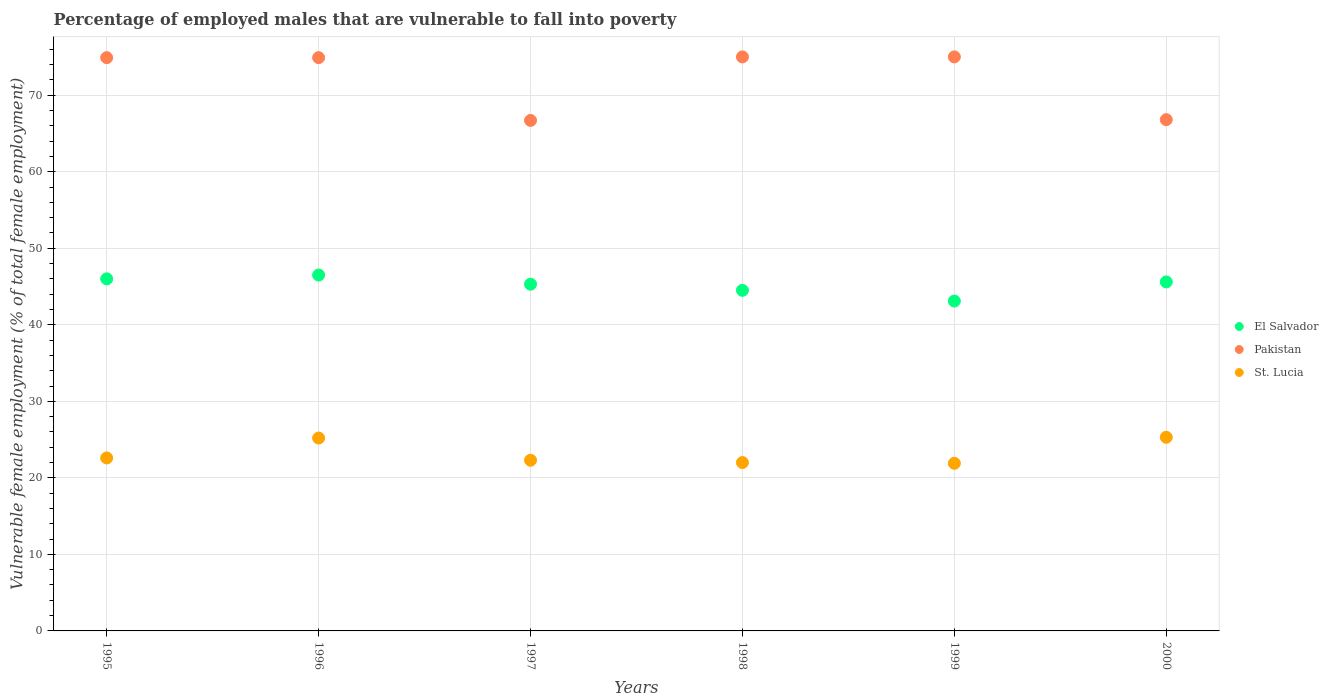Is the number of dotlines equal to the number of legend labels?
Provide a short and direct response. Yes. What is the percentage of employed males who are vulnerable to fall into poverty in Pakistan in 1996?
Your response must be concise. 74.9. Across all years, what is the maximum percentage of employed males who are vulnerable to fall into poverty in El Salvador?
Your answer should be compact. 46.5. Across all years, what is the minimum percentage of employed males who are vulnerable to fall into poverty in Pakistan?
Offer a very short reply. 66.7. In which year was the percentage of employed males who are vulnerable to fall into poverty in El Salvador minimum?
Give a very brief answer. 1999. What is the total percentage of employed males who are vulnerable to fall into poverty in St. Lucia in the graph?
Keep it short and to the point. 139.3. What is the difference between the percentage of employed males who are vulnerable to fall into poverty in El Salvador in 1995 and that in 2000?
Make the answer very short. 0.4. What is the difference between the percentage of employed males who are vulnerable to fall into poverty in St. Lucia in 1995 and the percentage of employed males who are vulnerable to fall into poverty in Pakistan in 1997?
Your answer should be very brief. -44.1. What is the average percentage of employed males who are vulnerable to fall into poverty in El Salvador per year?
Provide a short and direct response. 45.17. In the year 1999, what is the difference between the percentage of employed males who are vulnerable to fall into poverty in St. Lucia and percentage of employed males who are vulnerable to fall into poverty in Pakistan?
Make the answer very short. -53.1. In how many years, is the percentage of employed males who are vulnerable to fall into poverty in Pakistan greater than 64 %?
Provide a succinct answer. 6. What is the ratio of the percentage of employed males who are vulnerable to fall into poverty in Pakistan in 1997 to that in 2000?
Provide a succinct answer. 1. Is the percentage of employed males who are vulnerable to fall into poverty in El Salvador in 1998 less than that in 2000?
Offer a very short reply. Yes. Is the difference between the percentage of employed males who are vulnerable to fall into poverty in St. Lucia in 1997 and 2000 greater than the difference between the percentage of employed males who are vulnerable to fall into poverty in Pakistan in 1997 and 2000?
Provide a succinct answer. No. What is the difference between the highest and the lowest percentage of employed males who are vulnerable to fall into poverty in El Salvador?
Your response must be concise. 3.4. In how many years, is the percentage of employed males who are vulnerable to fall into poverty in El Salvador greater than the average percentage of employed males who are vulnerable to fall into poverty in El Salvador taken over all years?
Offer a terse response. 4. Is the sum of the percentage of employed males who are vulnerable to fall into poverty in St. Lucia in 1997 and 1998 greater than the maximum percentage of employed males who are vulnerable to fall into poverty in El Salvador across all years?
Ensure brevity in your answer.  No. Is it the case that in every year, the sum of the percentage of employed males who are vulnerable to fall into poverty in St. Lucia and percentage of employed males who are vulnerable to fall into poverty in Pakistan  is greater than the percentage of employed males who are vulnerable to fall into poverty in El Salvador?
Offer a terse response. Yes. Does the percentage of employed males who are vulnerable to fall into poverty in St. Lucia monotonically increase over the years?
Make the answer very short. No. Is the percentage of employed males who are vulnerable to fall into poverty in Pakistan strictly less than the percentage of employed males who are vulnerable to fall into poverty in El Salvador over the years?
Ensure brevity in your answer.  No. How many years are there in the graph?
Your answer should be very brief. 6. What is the difference between two consecutive major ticks on the Y-axis?
Offer a terse response. 10. Are the values on the major ticks of Y-axis written in scientific E-notation?
Provide a succinct answer. No. What is the title of the graph?
Offer a very short reply. Percentage of employed males that are vulnerable to fall into poverty. What is the label or title of the Y-axis?
Provide a short and direct response. Vulnerable female employment (% of total female employment). What is the Vulnerable female employment (% of total female employment) of Pakistan in 1995?
Your answer should be compact. 74.9. What is the Vulnerable female employment (% of total female employment) of St. Lucia in 1995?
Your response must be concise. 22.6. What is the Vulnerable female employment (% of total female employment) of El Salvador in 1996?
Your response must be concise. 46.5. What is the Vulnerable female employment (% of total female employment) of Pakistan in 1996?
Give a very brief answer. 74.9. What is the Vulnerable female employment (% of total female employment) in St. Lucia in 1996?
Give a very brief answer. 25.2. What is the Vulnerable female employment (% of total female employment) of El Salvador in 1997?
Provide a succinct answer. 45.3. What is the Vulnerable female employment (% of total female employment) of Pakistan in 1997?
Give a very brief answer. 66.7. What is the Vulnerable female employment (% of total female employment) of St. Lucia in 1997?
Provide a short and direct response. 22.3. What is the Vulnerable female employment (% of total female employment) in El Salvador in 1998?
Give a very brief answer. 44.5. What is the Vulnerable female employment (% of total female employment) of Pakistan in 1998?
Provide a short and direct response. 75. What is the Vulnerable female employment (% of total female employment) in El Salvador in 1999?
Give a very brief answer. 43.1. What is the Vulnerable female employment (% of total female employment) in St. Lucia in 1999?
Your answer should be very brief. 21.9. What is the Vulnerable female employment (% of total female employment) in El Salvador in 2000?
Give a very brief answer. 45.6. What is the Vulnerable female employment (% of total female employment) in Pakistan in 2000?
Give a very brief answer. 66.8. What is the Vulnerable female employment (% of total female employment) of St. Lucia in 2000?
Provide a short and direct response. 25.3. Across all years, what is the maximum Vulnerable female employment (% of total female employment) of El Salvador?
Keep it short and to the point. 46.5. Across all years, what is the maximum Vulnerable female employment (% of total female employment) of Pakistan?
Your answer should be compact. 75. Across all years, what is the maximum Vulnerable female employment (% of total female employment) of St. Lucia?
Your answer should be very brief. 25.3. Across all years, what is the minimum Vulnerable female employment (% of total female employment) of El Salvador?
Your answer should be very brief. 43.1. Across all years, what is the minimum Vulnerable female employment (% of total female employment) of Pakistan?
Keep it short and to the point. 66.7. Across all years, what is the minimum Vulnerable female employment (% of total female employment) in St. Lucia?
Your response must be concise. 21.9. What is the total Vulnerable female employment (% of total female employment) in El Salvador in the graph?
Provide a short and direct response. 271. What is the total Vulnerable female employment (% of total female employment) of Pakistan in the graph?
Your answer should be compact. 433.3. What is the total Vulnerable female employment (% of total female employment) of St. Lucia in the graph?
Your answer should be compact. 139.3. What is the difference between the Vulnerable female employment (% of total female employment) in El Salvador in 1995 and that in 1996?
Your answer should be compact. -0.5. What is the difference between the Vulnerable female employment (% of total female employment) in Pakistan in 1995 and that in 1996?
Offer a terse response. 0. What is the difference between the Vulnerable female employment (% of total female employment) in St. Lucia in 1995 and that in 1996?
Your response must be concise. -2.6. What is the difference between the Vulnerable female employment (% of total female employment) in Pakistan in 1995 and that in 1997?
Keep it short and to the point. 8.2. What is the difference between the Vulnerable female employment (% of total female employment) in El Salvador in 1995 and that in 1998?
Offer a terse response. 1.5. What is the difference between the Vulnerable female employment (% of total female employment) of St. Lucia in 1995 and that in 1998?
Give a very brief answer. 0.6. What is the difference between the Vulnerable female employment (% of total female employment) in El Salvador in 1995 and that in 1999?
Keep it short and to the point. 2.9. What is the difference between the Vulnerable female employment (% of total female employment) of St. Lucia in 1995 and that in 1999?
Give a very brief answer. 0.7. What is the difference between the Vulnerable female employment (% of total female employment) in El Salvador in 1995 and that in 2000?
Ensure brevity in your answer.  0.4. What is the difference between the Vulnerable female employment (% of total female employment) in Pakistan in 1995 and that in 2000?
Make the answer very short. 8.1. What is the difference between the Vulnerable female employment (% of total female employment) of St. Lucia in 1995 and that in 2000?
Keep it short and to the point. -2.7. What is the difference between the Vulnerable female employment (% of total female employment) in Pakistan in 1996 and that in 1997?
Give a very brief answer. 8.2. What is the difference between the Vulnerable female employment (% of total female employment) of Pakistan in 1996 and that in 1999?
Offer a very short reply. -0.1. What is the difference between the Vulnerable female employment (% of total female employment) of El Salvador in 1996 and that in 2000?
Give a very brief answer. 0.9. What is the difference between the Vulnerable female employment (% of total female employment) of St. Lucia in 1996 and that in 2000?
Your answer should be compact. -0.1. What is the difference between the Vulnerable female employment (% of total female employment) of El Salvador in 1997 and that in 1998?
Provide a succinct answer. 0.8. What is the difference between the Vulnerable female employment (% of total female employment) in Pakistan in 1997 and that in 1998?
Ensure brevity in your answer.  -8.3. What is the difference between the Vulnerable female employment (% of total female employment) in St. Lucia in 1997 and that in 1999?
Offer a very short reply. 0.4. What is the difference between the Vulnerable female employment (% of total female employment) in St. Lucia in 1997 and that in 2000?
Offer a very short reply. -3. What is the difference between the Vulnerable female employment (% of total female employment) in Pakistan in 1998 and that in 1999?
Provide a short and direct response. 0. What is the difference between the Vulnerable female employment (% of total female employment) of St. Lucia in 1998 and that in 1999?
Keep it short and to the point. 0.1. What is the difference between the Vulnerable female employment (% of total female employment) in St. Lucia in 1998 and that in 2000?
Your response must be concise. -3.3. What is the difference between the Vulnerable female employment (% of total female employment) of El Salvador in 1999 and that in 2000?
Give a very brief answer. -2.5. What is the difference between the Vulnerable female employment (% of total female employment) of El Salvador in 1995 and the Vulnerable female employment (% of total female employment) of Pakistan in 1996?
Ensure brevity in your answer.  -28.9. What is the difference between the Vulnerable female employment (% of total female employment) of El Salvador in 1995 and the Vulnerable female employment (% of total female employment) of St. Lucia in 1996?
Your answer should be compact. 20.8. What is the difference between the Vulnerable female employment (% of total female employment) of Pakistan in 1995 and the Vulnerable female employment (% of total female employment) of St. Lucia in 1996?
Your answer should be compact. 49.7. What is the difference between the Vulnerable female employment (% of total female employment) of El Salvador in 1995 and the Vulnerable female employment (% of total female employment) of Pakistan in 1997?
Ensure brevity in your answer.  -20.7. What is the difference between the Vulnerable female employment (% of total female employment) of El Salvador in 1995 and the Vulnerable female employment (% of total female employment) of St. Lucia in 1997?
Provide a short and direct response. 23.7. What is the difference between the Vulnerable female employment (% of total female employment) of Pakistan in 1995 and the Vulnerable female employment (% of total female employment) of St. Lucia in 1997?
Your answer should be compact. 52.6. What is the difference between the Vulnerable female employment (% of total female employment) in El Salvador in 1995 and the Vulnerable female employment (% of total female employment) in Pakistan in 1998?
Provide a succinct answer. -29. What is the difference between the Vulnerable female employment (% of total female employment) in Pakistan in 1995 and the Vulnerable female employment (% of total female employment) in St. Lucia in 1998?
Your answer should be compact. 52.9. What is the difference between the Vulnerable female employment (% of total female employment) in El Salvador in 1995 and the Vulnerable female employment (% of total female employment) in St. Lucia in 1999?
Your response must be concise. 24.1. What is the difference between the Vulnerable female employment (% of total female employment) in Pakistan in 1995 and the Vulnerable female employment (% of total female employment) in St. Lucia in 1999?
Keep it short and to the point. 53. What is the difference between the Vulnerable female employment (% of total female employment) in El Salvador in 1995 and the Vulnerable female employment (% of total female employment) in Pakistan in 2000?
Offer a very short reply. -20.8. What is the difference between the Vulnerable female employment (% of total female employment) in El Salvador in 1995 and the Vulnerable female employment (% of total female employment) in St. Lucia in 2000?
Give a very brief answer. 20.7. What is the difference between the Vulnerable female employment (% of total female employment) in Pakistan in 1995 and the Vulnerable female employment (% of total female employment) in St. Lucia in 2000?
Your answer should be compact. 49.6. What is the difference between the Vulnerable female employment (% of total female employment) in El Salvador in 1996 and the Vulnerable female employment (% of total female employment) in Pakistan in 1997?
Your answer should be very brief. -20.2. What is the difference between the Vulnerable female employment (% of total female employment) of El Salvador in 1996 and the Vulnerable female employment (% of total female employment) of St. Lucia in 1997?
Keep it short and to the point. 24.2. What is the difference between the Vulnerable female employment (% of total female employment) in Pakistan in 1996 and the Vulnerable female employment (% of total female employment) in St. Lucia in 1997?
Provide a succinct answer. 52.6. What is the difference between the Vulnerable female employment (% of total female employment) in El Salvador in 1996 and the Vulnerable female employment (% of total female employment) in Pakistan in 1998?
Ensure brevity in your answer.  -28.5. What is the difference between the Vulnerable female employment (% of total female employment) of Pakistan in 1996 and the Vulnerable female employment (% of total female employment) of St. Lucia in 1998?
Offer a terse response. 52.9. What is the difference between the Vulnerable female employment (% of total female employment) of El Salvador in 1996 and the Vulnerable female employment (% of total female employment) of Pakistan in 1999?
Give a very brief answer. -28.5. What is the difference between the Vulnerable female employment (% of total female employment) in El Salvador in 1996 and the Vulnerable female employment (% of total female employment) in St. Lucia in 1999?
Ensure brevity in your answer.  24.6. What is the difference between the Vulnerable female employment (% of total female employment) in El Salvador in 1996 and the Vulnerable female employment (% of total female employment) in Pakistan in 2000?
Make the answer very short. -20.3. What is the difference between the Vulnerable female employment (% of total female employment) of El Salvador in 1996 and the Vulnerable female employment (% of total female employment) of St. Lucia in 2000?
Your answer should be compact. 21.2. What is the difference between the Vulnerable female employment (% of total female employment) in Pakistan in 1996 and the Vulnerable female employment (% of total female employment) in St. Lucia in 2000?
Offer a terse response. 49.6. What is the difference between the Vulnerable female employment (% of total female employment) in El Salvador in 1997 and the Vulnerable female employment (% of total female employment) in Pakistan in 1998?
Keep it short and to the point. -29.7. What is the difference between the Vulnerable female employment (% of total female employment) in El Salvador in 1997 and the Vulnerable female employment (% of total female employment) in St. Lucia in 1998?
Provide a succinct answer. 23.3. What is the difference between the Vulnerable female employment (% of total female employment) in Pakistan in 1997 and the Vulnerable female employment (% of total female employment) in St. Lucia in 1998?
Your response must be concise. 44.7. What is the difference between the Vulnerable female employment (% of total female employment) in El Salvador in 1997 and the Vulnerable female employment (% of total female employment) in Pakistan in 1999?
Provide a succinct answer. -29.7. What is the difference between the Vulnerable female employment (% of total female employment) in El Salvador in 1997 and the Vulnerable female employment (% of total female employment) in St. Lucia in 1999?
Give a very brief answer. 23.4. What is the difference between the Vulnerable female employment (% of total female employment) of Pakistan in 1997 and the Vulnerable female employment (% of total female employment) of St. Lucia in 1999?
Make the answer very short. 44.8. What is the difference between the Vulnerable female employment (% of total female employment) in El Salvador in 1997 and the Vulnerable female employment (% of total female employment) in Pakistan in 2000?
Provide a succinct answer. -21.5. What is the difference between the Vulnerable female employment (% of total female employment) of Pakistan in 1997 and the Vulnerable female employment (% of total female employment) of St. Lucia in 2000?
Offer a terse response. 41.4. What is the difference between the Vulnerable female employment (% of total female employment) in El Salvador in 1998 and the Vulnerable female employment (% of total female employment) in Pakistan in 1999?
Your answer should be compact. -30.5. What is the difference between the Vulnerable female employment (% of total female employment) in El Salvador in 1998 and the Vulnerable female employment (% of total female employment) in St. Lucia in 1999?
Your response must be concise. 22.6. What is the difference between the Vulnerable female employment (% of total female employment) in Pakistan in 1998 and the Vulnerable female employment (% of total female employment) in St. Lucia in 1999?
Your response must be concise. 53.1. What is the difference between the Vulnerable female employment (% of total female employment) in El Salvador in 1998 and the Vulnerable female employment (% of total female employment) in Pakistan in 2000?
Give a very brief answer. -22.3. What is the difference between the Vulnerable female employment (% of total female employment) of El Salvador in 1998 and the Vulnerable female employment (% of total female employment) of St. Lucia in 2000?
Give a very brief answer. 19.2. What is the difference between the Vulnerable female employment (% of total female employment) of Pakistan in 1998 and the Vulnerable female employment (% of total female employment) of St. Lucia in 2000?
Make the answer very short. 49.7. What is the difference between the Vulnerable female employment (% of total female employment) of El Salvador in 1999 and the Vulnerable female employment (% of total female employment) of Pakistan in 2000?
Make the answer very short. -23.7. What is the difference between the Vulnerable female employment (% of total female employment) of El Salvador in 1999 and the Vulnerable female employment (% of total female employment) of St. Lucia in 2000?
Offer a very short reply. 17.8. What is the difference between the Vulnerable female employment (% of total female employment) of Pakistan in 1999 and the Vulnerable female employment (% of total female employment) of St. Lucia in 2000?
Provide a succinct answer. 49.7. What is the average Vulnerable female employment (% of total female employment) of El Salvador per year?
Give a very brief answer. 45.17. What is the average Vulnerable female employment (% of total female employment) of Pakistan per year?
Provide a succinct answer. 72.22. What is the average Vulnerable female employment (% of total female employment) in St. Lucia per year?
Your answer should be compact. 23.22. In the year 1995, what is the difference between the Vulnerable female employment (% of total female employment) in El Salvador and Vulnerable female employment (% of total female employment) in Pakistan?
Offer a very short reply. -28.9. In the year 1995, what is the difference between the Vulnerable female employment (% of total female employment) in El Salvador and Vulnerable female employment (% of total female employment) in St. Lucia?
Your answer should be compact. 23.4. In the year 1995, what is the difference between the Vulnerable female employment (% of total female employment) of Pakistan and Vulnerable female employment (% of total female employment) of St. Lucia?
Keep it short and to the point. 52.3. In the year 1996, what is the difference between the Vulnerable female employment (% of total female employment) of El Salvador and Vulnerable female employment (% of total female employment) of Pakistan?
Offer a terse response. -28.4. In the year 1996, what is the difference between the Vulnerable female employment (% of total female employment) in El Salvador and Vulnerable female employment (% of total female employment) in St. Lucia?
Make the answer very short. 21.3. In the year 1996, what is the difference between the Vulnerable female employment (% of total female employment) of Pakistan and Vulnerable female employment (% of total female employment) of St. Lucia?
Offer a very short reply. 49.7. In the year 1997, what is the difference between the Vulnerable female employment (% of total female employment) in El Salvador and Vulnerable female employment (% of total female employment) in Pakistan?
Make the answer very short. -21.4. In the year 1997, what is the difference between the Vulnerable female employment (% of total female employment) in El Salvador and Vulnerable female employment (% of total female employment) in St. Lucia?
Your answer should be very brief. 23. In the year 1997, what is the difference between the Vulnerable female employment (% of total female employment) of Pakistan and Vulnerable female employment (% of total female employment) of St. Lucia?
Give a very brief answer. 44.4. In the year 1998, what is the difference between the Vulnerable female employment (% of total female employment) of El Salvador and Vulnerable female employment (% of total female employment) of Pakistan?
Your answer should be compact. -30.5. In the year 1999, what is the difference between the Vulnerable female employment (% of total female employment) of El Salvador and Vulnerable female employment (% of total female employment) of Pakistan?
Your response must be concise. -31.9. In the year 1999, what is the difference between the Vulnerable female employment (% of total female employment) in El Salvador and Vulnerable female employment (% of total female employment) in St. Lucia?
Your response must be concise. 21.2. In the year 1999, what is the difference between the Vulnerable female employment (% of total female employment) of Pakistan and Vulnerable female employment (% of total female employment) of St. Lucia?
Provide a short and direct response. 53.1. In the year 2000, what is the difference between the Vulnerable female employment (% of total female employment) in El Salvador and Vulnerable female employment (% of total female employment) in Pakistan?
Offer a terse response. -21.2. In the year 2000, what is the difference between the Vulnerable female employment (% of total female employment) of El Salvador and Vulnerable female employment (% of total female employment) of St. Lucia?
Offer a very short reply. 20.3. In the year 2000, what is the difference between the Vulnerable female employment (% of total female employment) in Pakistan and Vulnerable female employment (% of total female employment) in St. Lucia?
Your response must be concise. 41.5. What is the ratio of the Vulnerable female employment (% of total female employment) in El Salvador in 1995 to that in 1996?
Provide a short and direct response. 0.99. What is the ratio of the Vulnerable female employment (% of total female employment) in Pakistan in 1995 to that in 1996?
Provide a succinct answer. 1. What is the ratio of the Vulnerable female employment (% of total female employment) in St. Lucia in 1995 to that in 1996?
Offer a terse response. 0.9. What is the ratio of the Vulnerable female employment (% of total female employment) in El Salvador in 1995 to that in 1997?
Offer a terse response. 1.02. What is the ratio of the Vulnerable female employment (% of total female employment) in Pakistan in 1995 to that in 1997?
Provide a short and direct response. 1.12. What is the ratio of the Vulnerable female employment (% of total female employment) of St. Lucia in 1995 to that in 1997?
Make the answer very short. 1.01. What is the ratio of the Vulnerable female employment (% of total female employment) in El Salvador in 1995 to that in 1998?
Make the answer very short. 1.03. What is the ratio of the Vulnerable female employment (% of total female employment) in St. Lucia in 1995 to that in 1998?
Provide a succinct answer. 1.03. What is the ratio of the Vulnerable female employment (% of total female employment) in El Salvador in 1995 to that in 1999?
Make the answer very short. 1.07. What is the ratio of the Vulnerable female employment (% of total female employment) in St. Lucia in 1995 to that in 1999?
Give a very brief answer. 1.03. What is the ratio of the Vulnerable female employment (% of total female employment) of El Salvador in 1995 to that in 2000?
Offer a very short reply. 1.01. What is the ratio of the Vulnerable female employment (% of total female employment) in Pakistan in 1995 to that in 2000?
Give a very brief answer. 1.12. What is the ratio of the Vulnerable female employment (% of total female employment) of St. Lucia in 1995 to that in 2000?
Your response must be concise. 0.89. What is the ratio of the Vulnerable female employment (% of total female employment) of El Salvador in 1996 to that in 1997?
Make the answer very short. 1.03. What is the ratio of the Vulnerable female employment (% of total female employment) of Pakistan in 1996 to that in 1997?
Offer a terse response. 1.12. What is the ratio of the Vulnerable female employment (% of total female employment) in St. Lucia in 1996 to that in 1997?
Provide a short and direct response. 1.13. What is the ratio of the Vulnerable female employment (% of total female employment) of El Salvador in 1996 to that in 1998?
Your answer should be compact. 1.04. What is the ratio of the Vulnerable female employment (% of total female employment) of Pakistan in 1996 to that in 1998?
Ensure brevity in your answer.  1. What is the ratio of the Vulnerable female employment (% of total female employment) in St. Lucia in 1996 to that in 1998?
Offer a very short reply. 1.15. What is the ratio of the Vulnerable female employment (% of total female employment) in El Salvador in 1996 to that in 1999?
Your response must be concise. 1.08. What is the ratio of the Vulnerable female employment (% of total female employment) of St. Lucia in 1996 to that in 1999?
Make the answer very short. 1.15. What is the ratio of the Vulnerable female employment (% of total female employment) in El Salvador in 1996 to that in 2000?
Offer a terse response. 1.02. What is the ratio of the Vulnerable female employment (% of total female employment) in Pakistan in 1996 to that in 2000?
Offer a very short reply. 1.12. What is the ratio of the Vulnerable female employment (% of total female employment) of St. Lucia in 1996 to that in 2000?
Offer a terse response. 1. What is the ratio of the Vulnerable female employment (% of total female employment) of Pakistan in 1997 to that in 1998?
Offer a very short reply. 0.89. What is the ratio of the Vulnerable female employment (% of total female employment) in St. Lucia in 1997 to that in 1998?
Make the answer very short. 1.01. What is the ratio of the Vulnerable female employment (% of total female employment) in El Salvador in 1997 to that in 1999?
Your answer should be compact. 1.05. What is the ratio of the Vulnerable female employment (% of total female employment) in Pakistan in 1997 to that in 1999?
Make the answer very short. 0.89. What is the ratio of the Vulnerable female employment (% of total female employment) of St. Lucia in 1997 to that in 1999?
Provide a succinct answer. 1.02. What is the ratio of the Vulnerable female employment (% of total female employment) of El Salvador in 1997 to that in 2000?
Provide a short and direct response. 0.99. What is the ratio of the Vulnerable female employment (% of total female employment) of St. Lucia in 1997 to that in 2000?
Your answer should be very brief. 0.88. What is the ratio of the Vulnerable female employment (% of total female employment) of El Salvador in 1998 to that in 1999?
Provide a succinct answer. 1.03. What is the ratio of the Vulnerable female employment (% of total female employment) of El Salvador in 1998 to that in 2000?
Give a very brief answer. 0.98. What is the ratio of the Vulnerable female employment (% of total female employment) in Pakistan in 1998 to that in 2000?
Make the answer very short. 1.12. What is the ratio of the Vulnerable female employment (% of total female employment) in St. Lucia in 1998 to that in 2000?
Provide a short and direct response. 0.87. What is the ratio of the Vulnerable female employment (% of total female employment) of El Salvador in 1999 to that in 2000?
Provide a succinct answer. 0.95. What is the ratio of the Vulnerable female employment (% of total female employment) of Pakistan in 1999 to that in 2000?
Provide a short and direct response. 1.12. What is the ratio of the Vulnerable female employment (% of total female employment) of St. Lucia in 1999 to that in 2000?
Ensure brevity in your answer.  0.87. What is the difference between the highest and the second highest Vulnerable female employment (% of total female employment) in El Salvador?
Ensure brevity in your answer.  0.5. What is the difference between the highest and the lowest Vulnerable female employment (% of total female employment) in El Salvador?
Ensure brevity in your answer.  3.4. What is the difference between the highest and the lowest Vulnerable female employment (% of total female employment) of St. Lucia?
Offer a very short reply. 3.4. 